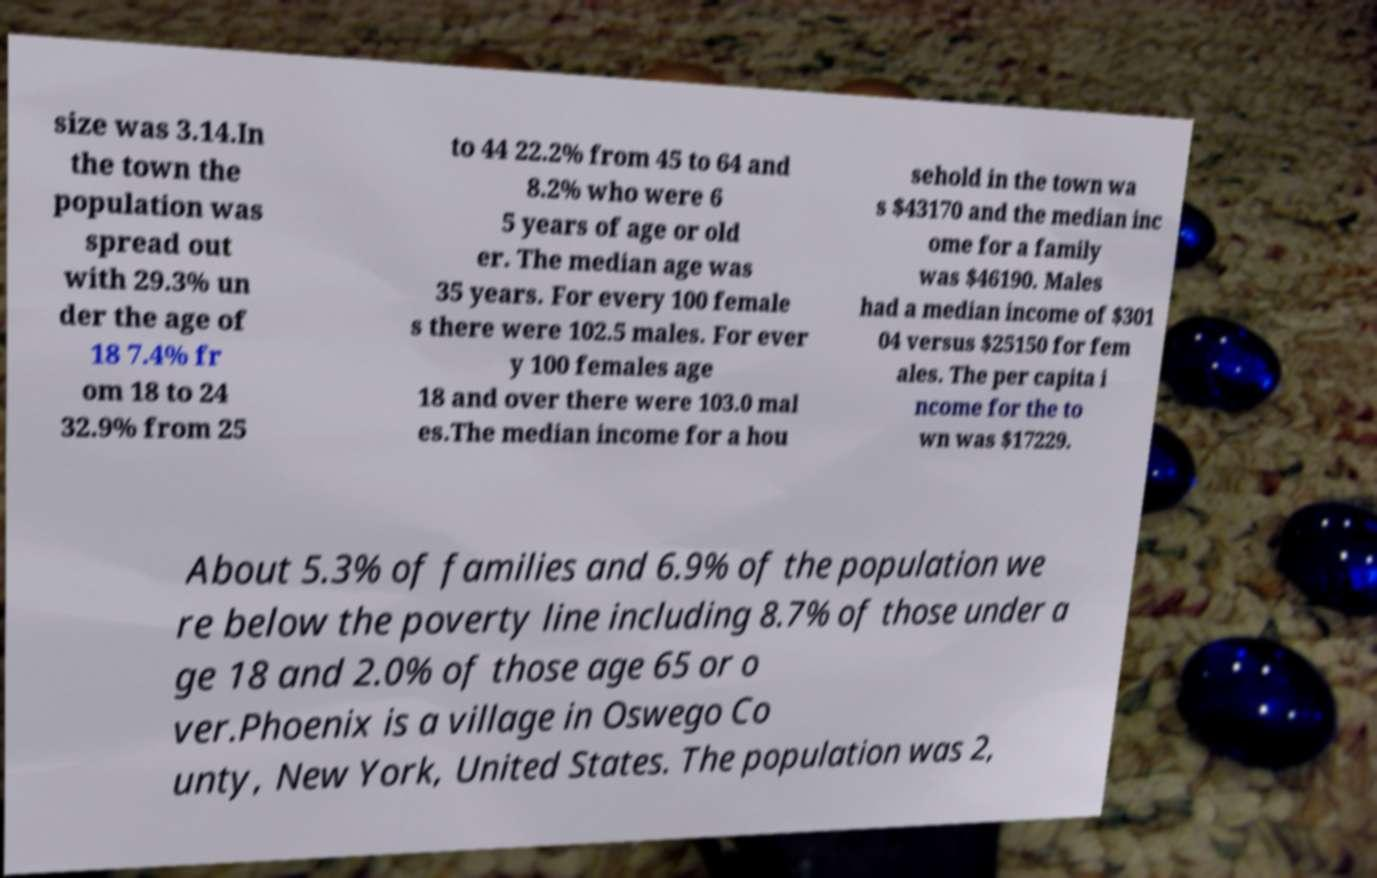Can you read and provide the text displayed in the image?This photo seems to have some interesting text. Can you extract and type it out for me? size was 3.14.In the town the population was spread out with 29.3% un der the age of 18 7.4% fr om 18 to 24 32.9% from 25 to 44 22.2% from 45 to 64 and 8.2% who were 6 5 years of age or old er. The median age was 35 years. For every 100 female s there were 102.5 males. For ever y 100 females age 18 and over there were 103.0 mal es.The median income for a hou sehold in the town wa s $43170 and the median inc ome for a family was $46190. Males had a median income of $301 04 versus $25150 for fem ales. The per capita i ncome for the to wn was $17229. About 5.3% of families and 6.9% of the population we re below the poverty line including 8.7% of those under a ge 18 and 2.0% of those age 65 or o ver.Phoenix is a village in Oswego Co unty, New York, United States. The population was 2, 